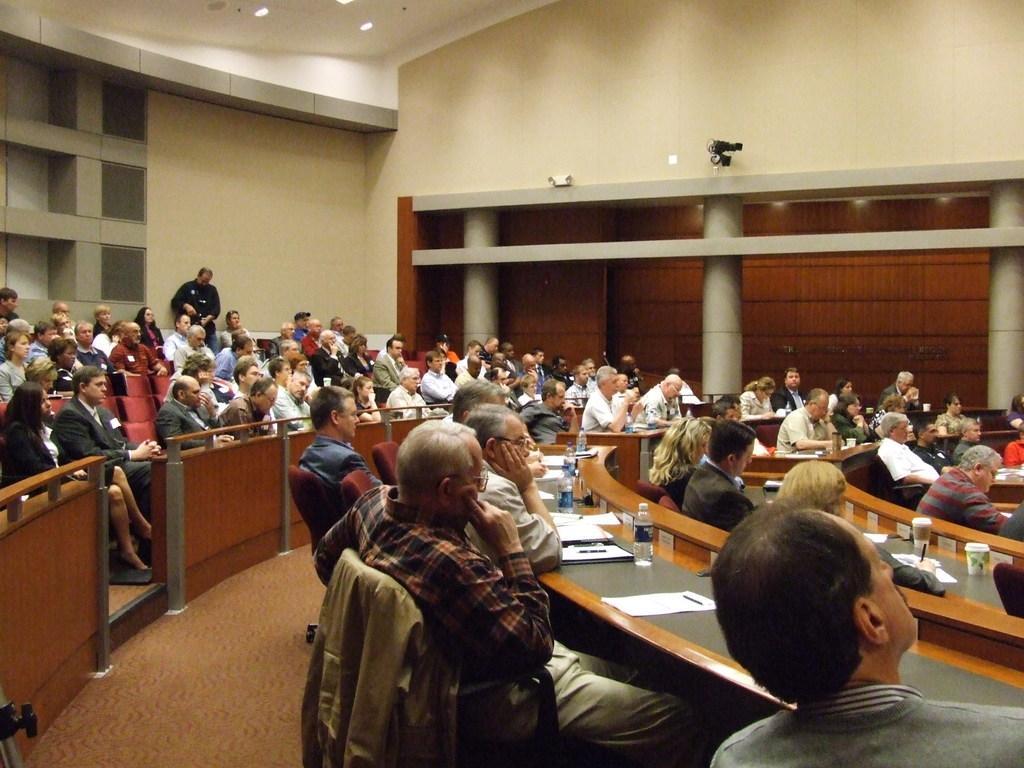Could you give a brief overview of what you see in this image? In this picture we can see a crowd of people sitting on seats and some are sitting on chairs and in front of them there is table and on table we can see paper, pen bottle, glass and on this chair we have jacket and in background we can see wall, pillar, light. 